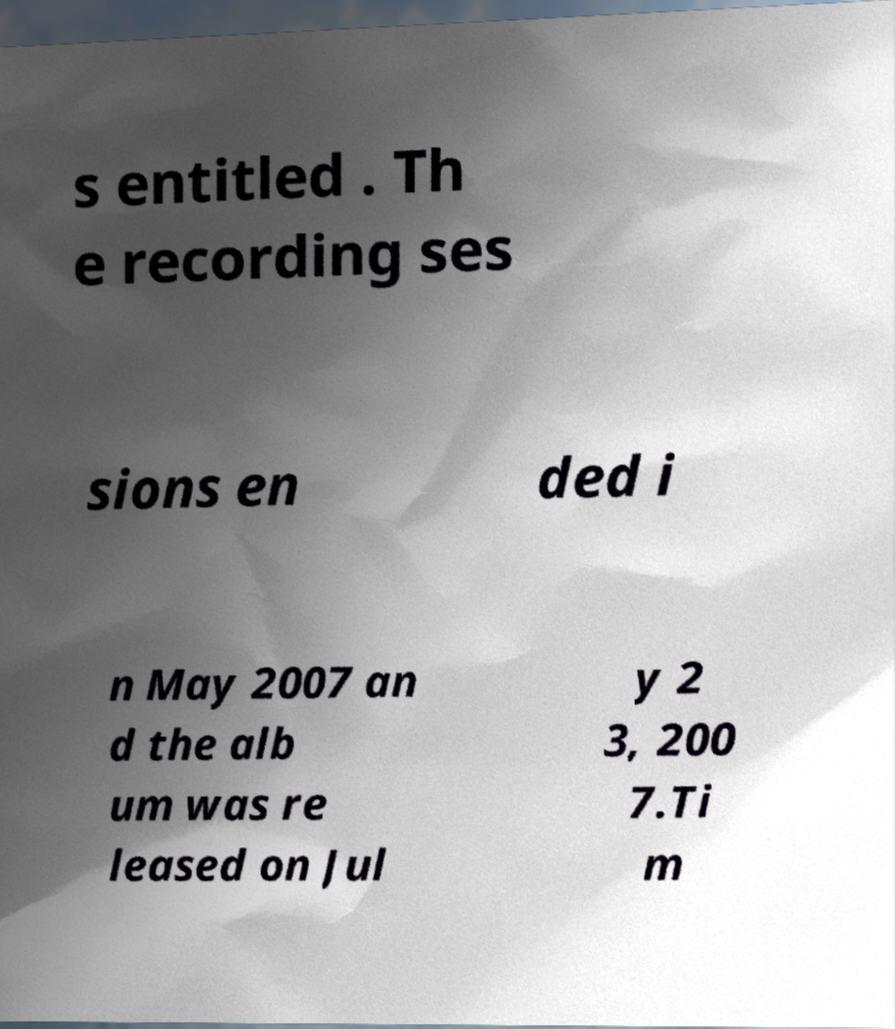I need the written content from this picture converted into text. Can you do that? s entitled . Th e recording ses sions en ded i n May 2007 an d the alb um was re leased on Jul y 2 3, 200 7.Ti m 